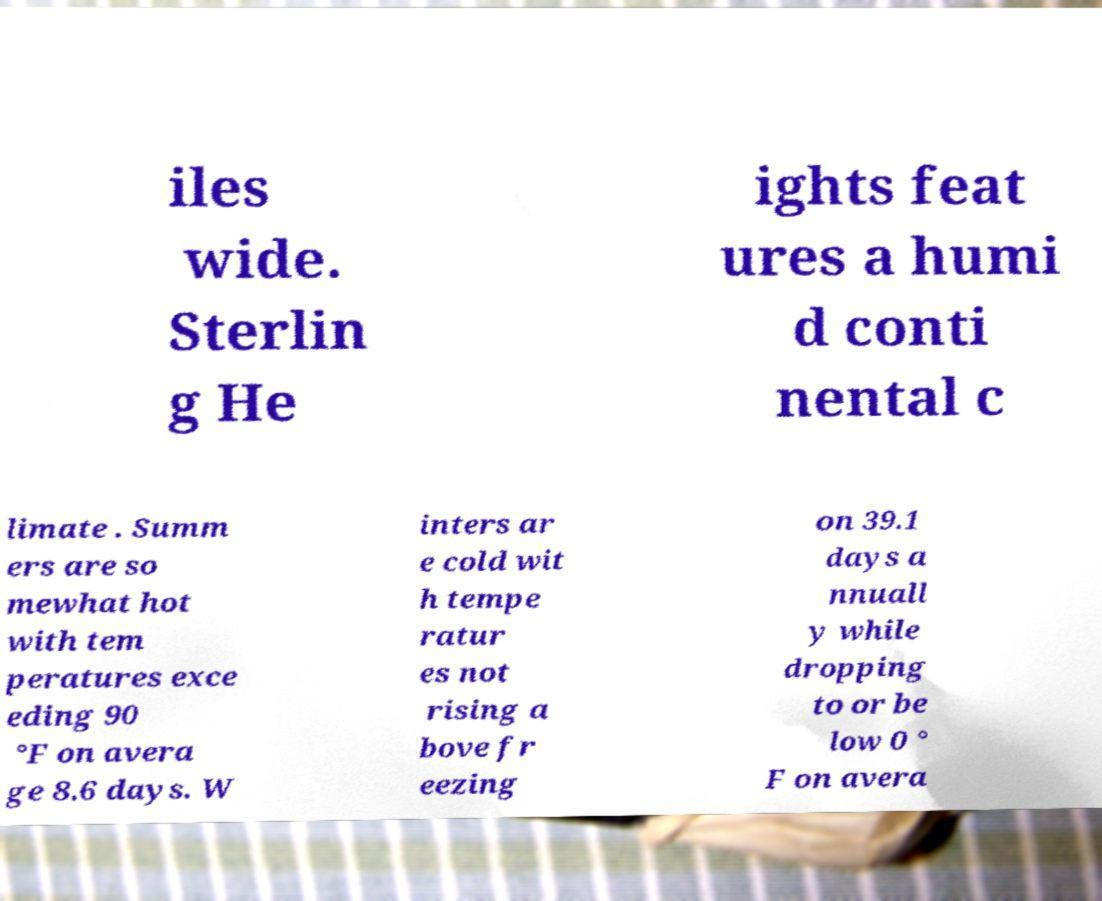There's text embedded in this image that I need extracted. Can you transcribe it verbatim? iles wide. Sterlin g He ights feat ures a humi d conti nental c limate . Summ ers are so mewhat hot with tem peratures exce eding 90 °F on avera ge 8.6 days. W inters ar e cold wit h tempe ratur es not rising a bove fr eezing on 39.1 days a nnuall y while dropping to or be low 0 ° F on avera 